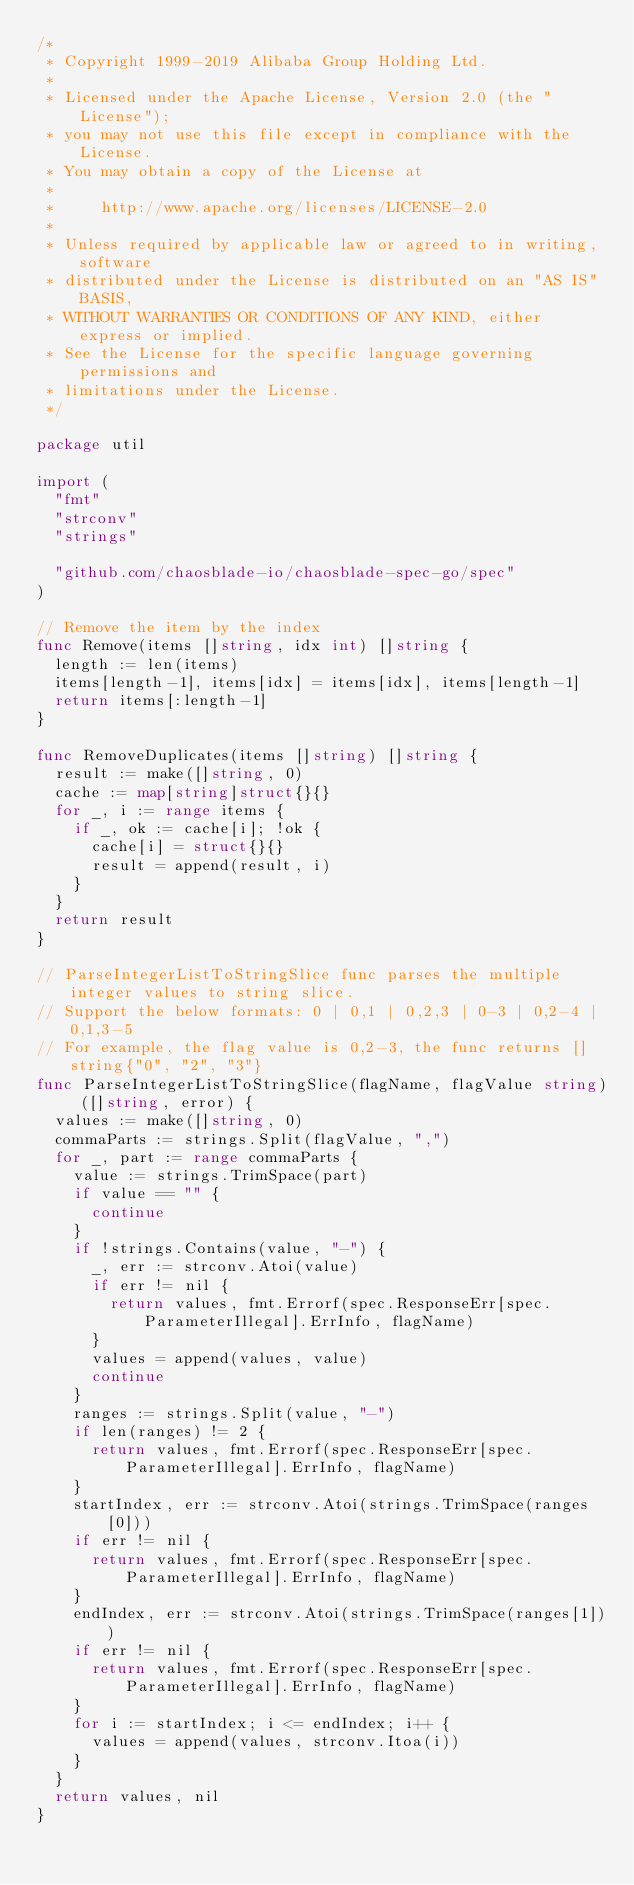<code> <loc_0><loc_0><loc_500><loc_500><_Go_>/*
 * Copyright 1999-2019 Alibaba Group Holding Ltd.
 *
 * Licensed under the Apache License, Version 2.0 (the "License");
 * you may not use this file except in compliance with the License.
 * You may obtain a copy of the License at
 *
 *     http://www.apache.org/licenses/LICENSE-2.0
 *
 * Unless required by applicable law or agreed to in writing, software
 * distributed under the License is distributed on an "AS IS" BASIS,
 * WITHOUT WARRANTIES OR CONDITIONS OF ANY KIND, either express or implied.
 * See the License for the specific language governing permissions and
 * limitations under the License.
 */

package util

import (
	"fmt"
	"strconv"
	"strings"

	"github.com/chaosblade-io/chaosblade-spec-go/spec"
)

// Remove the item by the index
func Remove(items []string, idx int) []string {
	length := len(items)
	items[length-1], items[idx] = items[idx], items[length-1]
	return items[:length-1]
}

func RemoveDuplicates(items []string) []string {
	result := make([]string, 0)
	cache := map[string]struct{}{}
	for _, i := range items {
		if _, ok := cache[i]; !ok {
			cache[i] = struct{}{}
			result = append(result, i)
		}
	}
	return result
}

// ParseIntegerListToStringSlice func parses the multiple integer values to string slice.
// Support the below formats: 0 | 0,1 | 0,2,3 | 0-3 | 0,2-4 | 0,1,3-5
// For example, the flag value is 0,2-3, the func returns []string{"0", "2", "3"}
func ParseIntegerListToStringSlice(flagName, flagValue string) ([]string, error) {
	values := make([]string, 0)
	commaParts := strings.Split(flagValue, ",")
	for _, part := range commaParts {
		value := strings.TrimSpace(part)
		if value == "" {
			continue
		}
		if !strings.Contains(value, "-") {
			_, err := strconv.Atoi(value)
			if err != nil {
				return values, fmt.Errorf(spec.ResponseErr[spec.ParameterIllegal].ErrInfo, flagName)
			}
			values = append(values, value)
			continue
		}
		ranges := strings.Split(value, "-")
		if len(ranges) != 2 {
			return values, fmt.Errorf(spec.ResponseErr[spec.ParameterIllegal].ErrInfo, flagName)
		}
		startIndex, err := strconv.Atoi(strings.TrimSpace(ranges[0]))
		if err != nil {
			return values, fmt.Errorf(spec.ResponseErr[spec.ParameterIllegal].ErrInfo, flagName)
		}
		endIndex, err := strconv.Atoi(strings.TrimSpace(ranges[1]))
		if err != nil {
			return values, fmt.Errorf(spec.ResponseErr[spec.ParameterIllegal].ErrInfo, flagName)
		}
		for i := startIndex; i <= endIndex; i++ {
			values = append(values, strconv.Itoa(i))
		}
	}
	return values, nil
}
</code> 